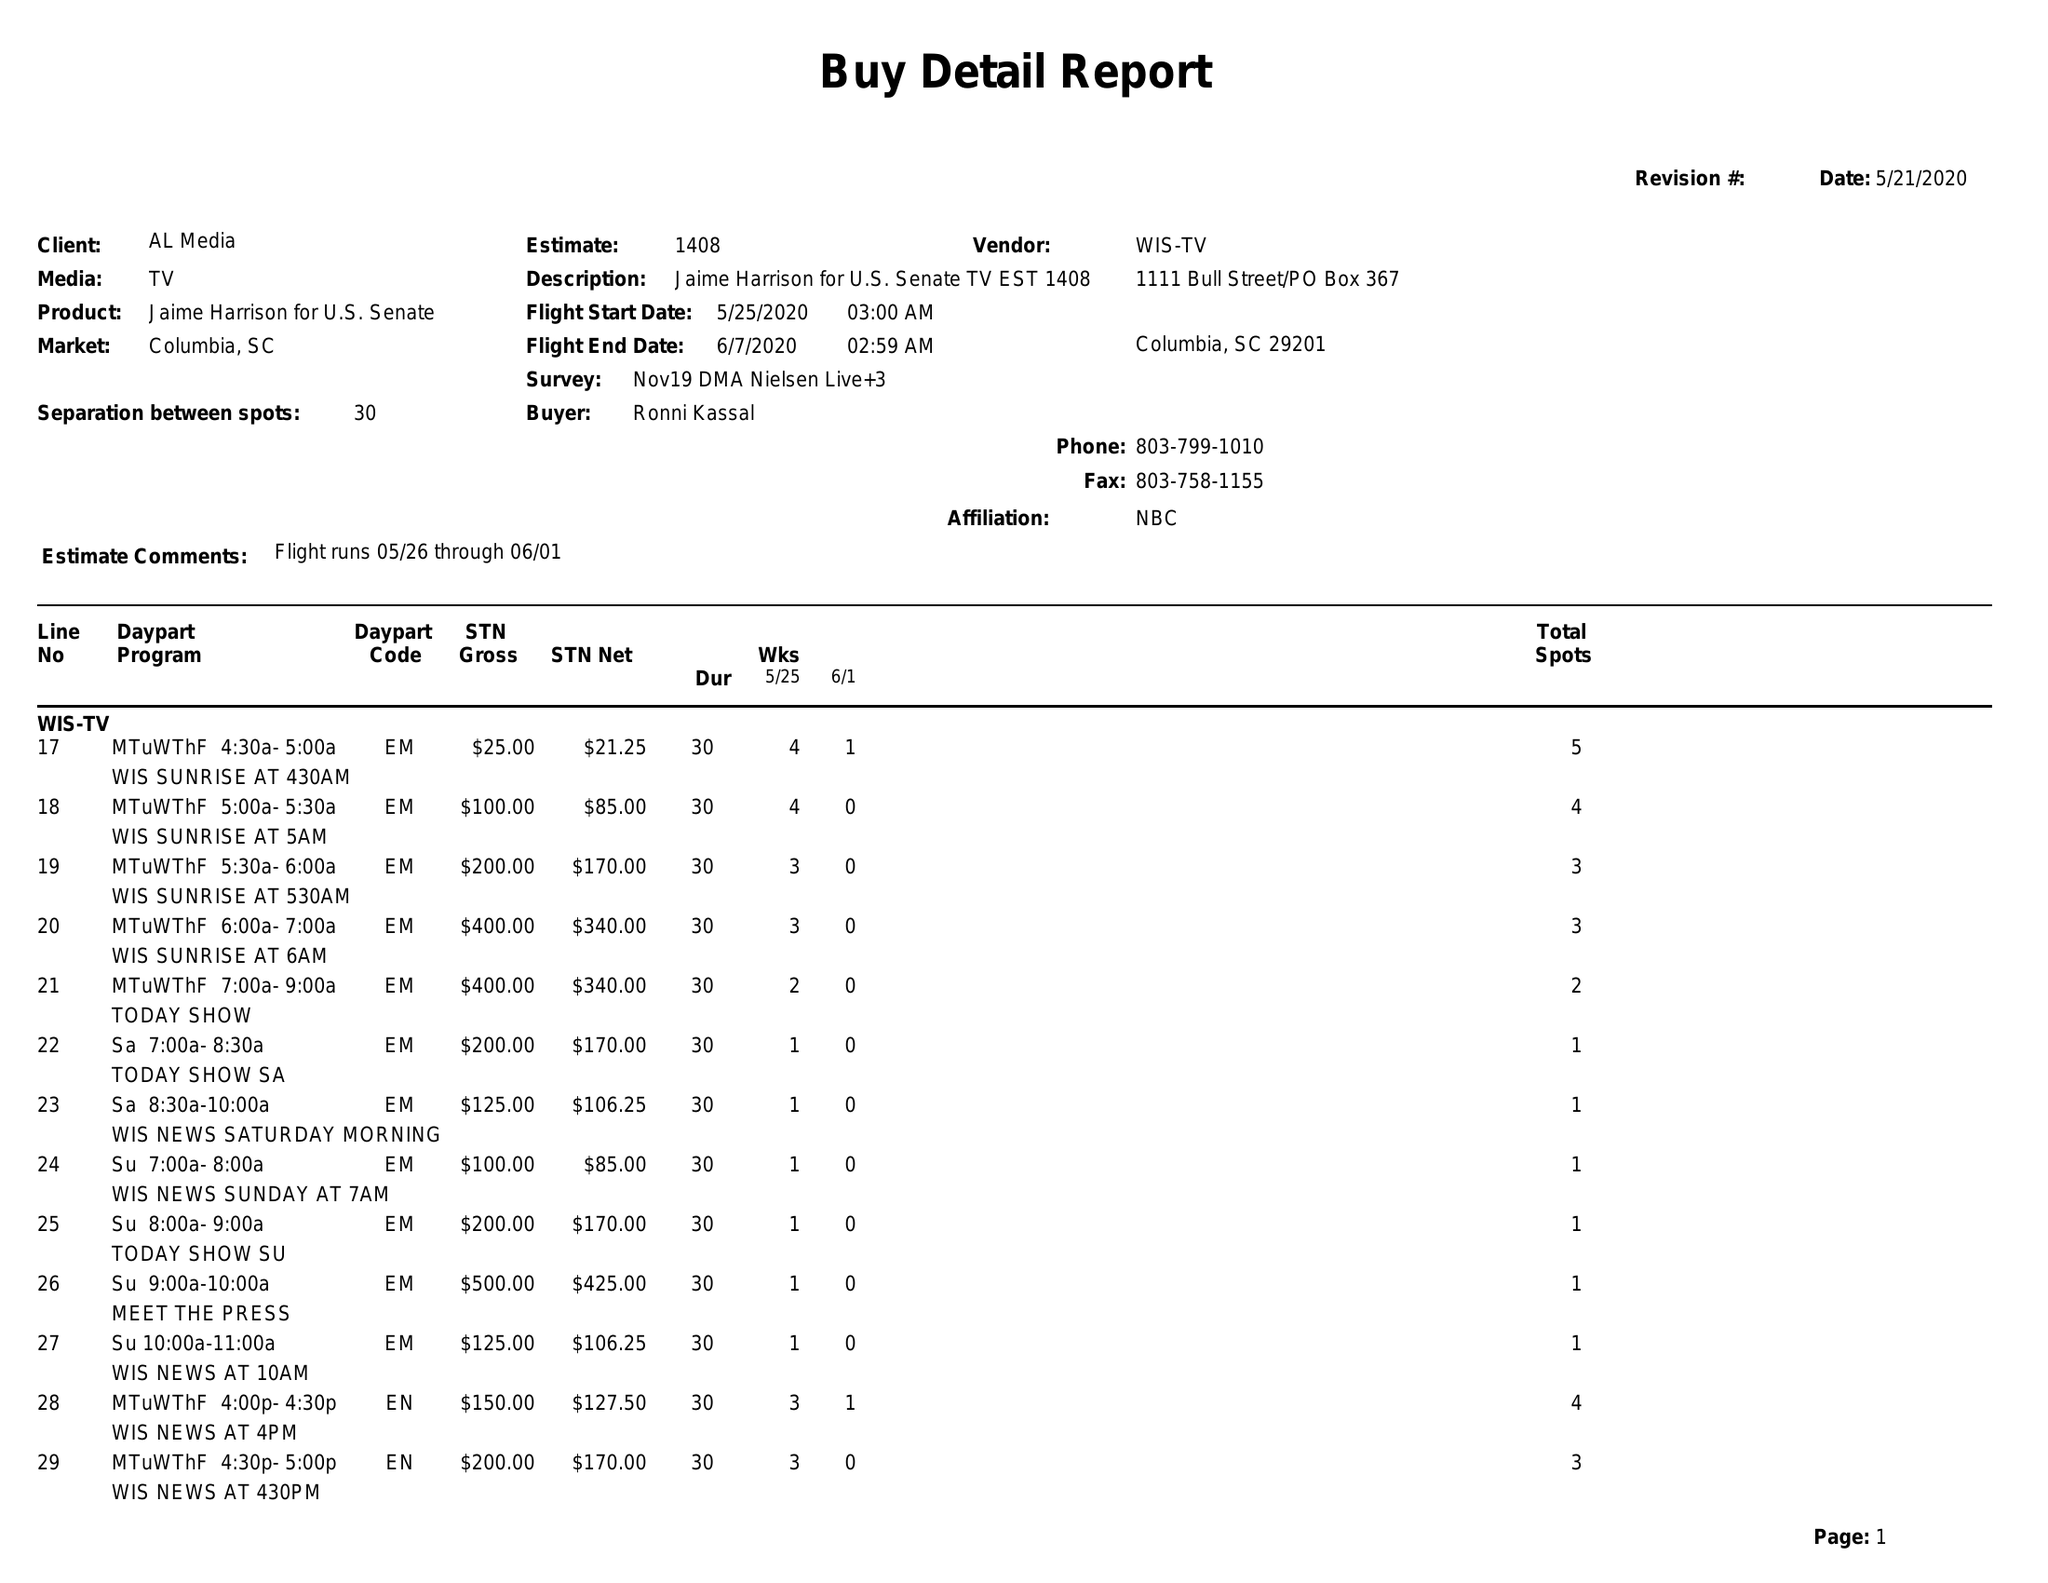What is the value for the flight_to?
Answer the question using a single word or phrase. 06/07/20 